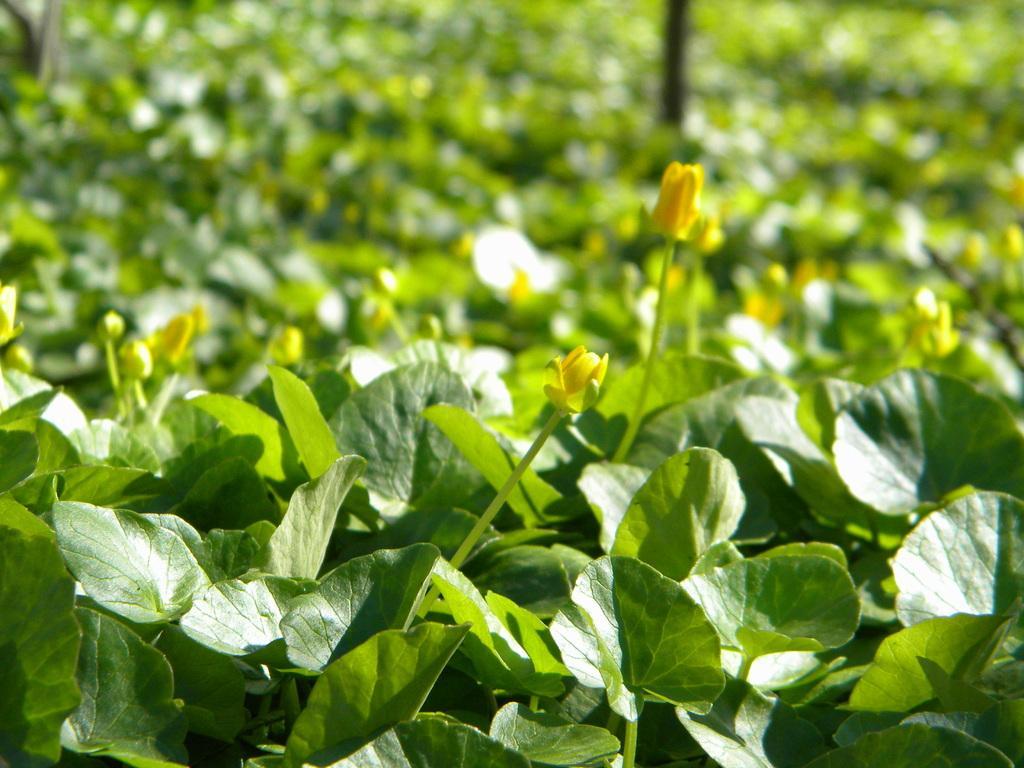Can you describe this image briefly? In this picture, we see plants and these plants have flowers. These flowers are in yellow color. In the background, we see plants and a pole. It is blurred, in the background. 